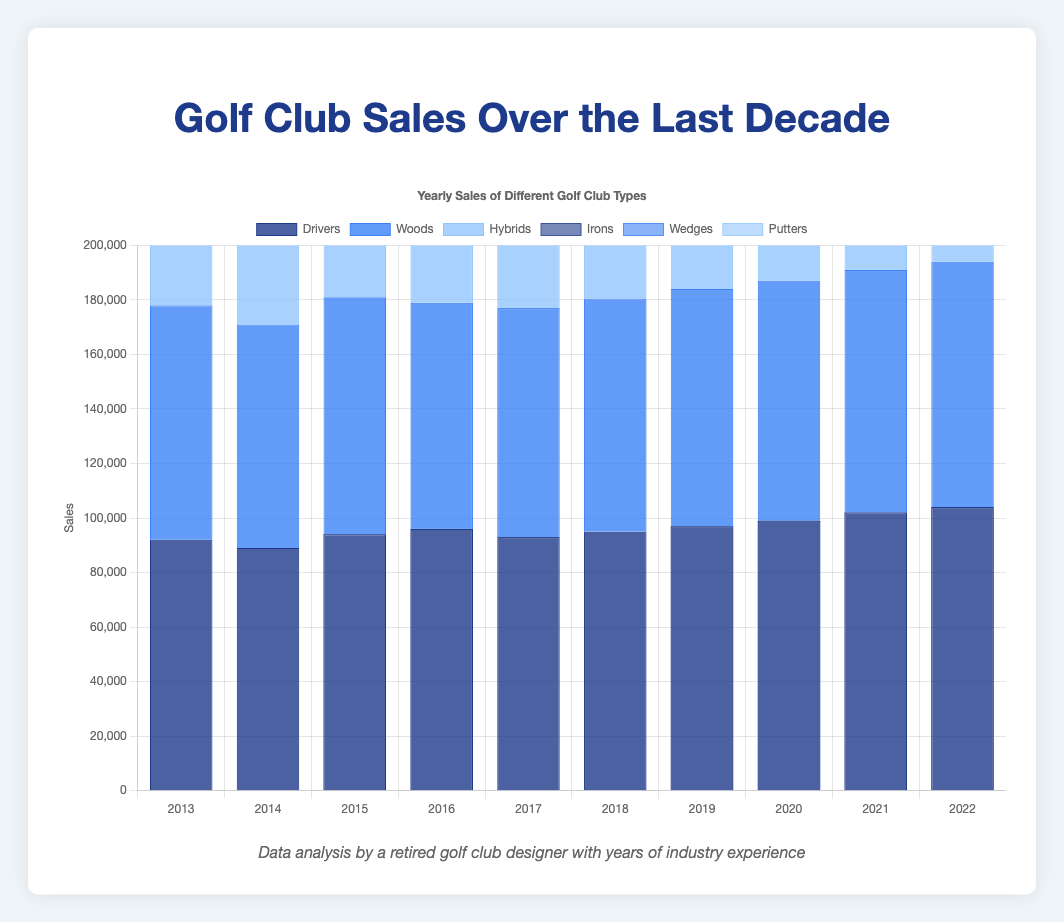What is the total sales for the year 2022 across all types of golf clubs? To determine the total sales for all types of golf clubs in 2022, add the sales of Drivers (104,000), Woods (90,000), Hybrids (84,000), Irons (164,000), Wedges (78,000), and Putters (67,000). The sum is 104000 + 90000 + 84000 + 164000 + 78000 + 67000 = 587,000.
Answer: 587,000 Which type of golf club had the highest sales in 2021? Looking at the 2021 data, the sales are Drivers (102,000), Woods (89,000), Hybrids (83,000), Irons (162,000), Wedges (77,000), and Putters (66,000). The highest sales figure is for Irons with 162,000.
Answer: Irons Did sales for Drivers increase or decrease from 2013 to 2022, and by how much? The sales for Drivers in 2013 were 92,000, and in 2022, they were 104,000. To find the difference: 104,000 - 92,000 = 12,000. Therefore, sales increased by 12,000.
Answer: Increased by 12,000 In which year did Irons sales surpass 160,000? Reviewing the yearly sales data for Irons, they surpassed 160,000 in 2019 with 160,000 sales, and continued to stay above this mark in 2020, 2021, and 2022. The first year this happened is 2019.
Answer: 2019 What was the difference in sales between Drivers and Putters in 2020? To find the difference in sales between Drivers (99,000) and Putters (64,000) in 2020, subtract the Putters' sales from the Drivers' sales: 99,000 - 64,000 = 35,000.
Answer: 35,000 Which type of golf club had the most consistent sales (i.e., smallest fluctuation) over the decade? To determine which club had the most consistent sales, examine the range of sales data for each type. Drivers’ sales range from 89,000 to 104,000, Woods from 82,000 to 90,000, Hybrids from 73,000 to 84,000, Irons from 145,000 to 164,000, Wedges from 69,000 to 78,000, and Putters from 61,000 to 67,000. Hybrids have the smallest range of sales (84,000 - 73,000 = 11,000).
Answer: Hybrids How do the sales of Wedges in 2016 compare proportionally to the sales of Irons in the same year? To compare proportionally, divide Wedges sales (72,000) by Irons sales (151,000) for 2016: 72,000 / 151,000 ≈ 0.477. Therefore, Wedges' sales are approximately 47.7% of Irons’ sales in that year.
Answer: 47.7% What was the average yearly sales of Putters over the last decade? To find the average yearly sales of Putters, sum the sales from 2013 to 2022 and divide by 10: (66,000 + 64,000 + 62,000 + 65,000 + 63,000 + 61,000 + 62,000 + 64,000 + 66,000 + 67,000) / 10 = 640,000 / 10 = 64,000.
Answer: 64,000 